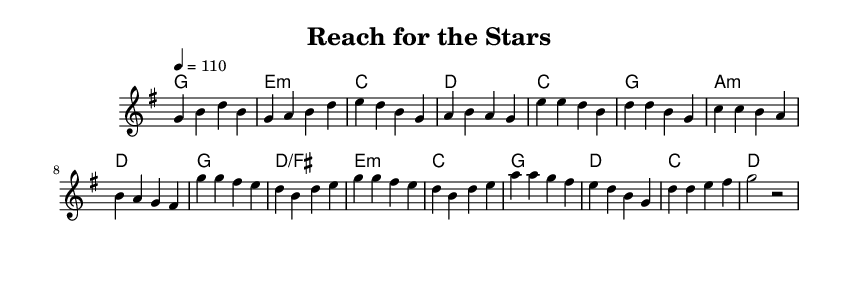What is the key signature of this music? The key signature is G major, which contains one sharp (F#). It can be identified by looking at the beginning of the staff where the key signature is indicated.
Answer: G major What is the time signature of this piece? The time signature is 4/4, which means there are four beats in each measure, and the quarter note gets one beat. This is indicated at the beginning of the score.
Answer: 4/4 What is the tempo marking for this piece? The tempo marking is 110 beats per minute, shown with the 'tempo' indication at the start. This indicates how fast the piece should be played.
Answer: 110 How many measures are in the chorus section? The chorus section has eight measures, which can be determined by counting the measures marked in that part of the score.
Answer: Eight What do the lyrics in the chorus express? The lyrics in the chorus express determination and the aspiration to succeed, which is central to the theme of pursuing dreams. The desire to overcome challenges is highlighted by phrases like "I won't give in."
Answer: Aspiration What is the pattern of harmony used in the verse? The harmony pattern in the verse follows a specific progression of chords, starting with G major, shifting to E minor, then C major, and finally D major across four measures. This creates a cohesive sound that supports the melody.
Answer: G, E minor, C, D What message do the lyrics in the pre-chorus convey? The lyrics in the pre-chorus convey resilience and determination, stating that despite obstacles, there is a commitment to pushing forward. This reflects a mindset that aligns closely with that of aspiring athletes aiming to overcome hurdles.
Answer: Resilience 